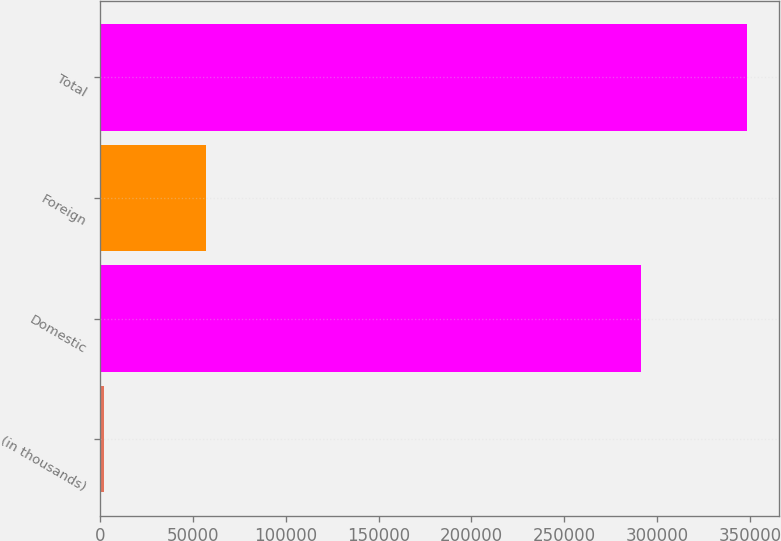Convert chart to OTSL. <chart><loc_0><loc_0><loc_500><loc_500><bar_chart><fcel>(in thousands)<fcel>Domestic<fcel>Foreign<fcel>Total<nl><fcel>2014<fcel>291042<fcel>57097<fcel>348139<nl></chart> 